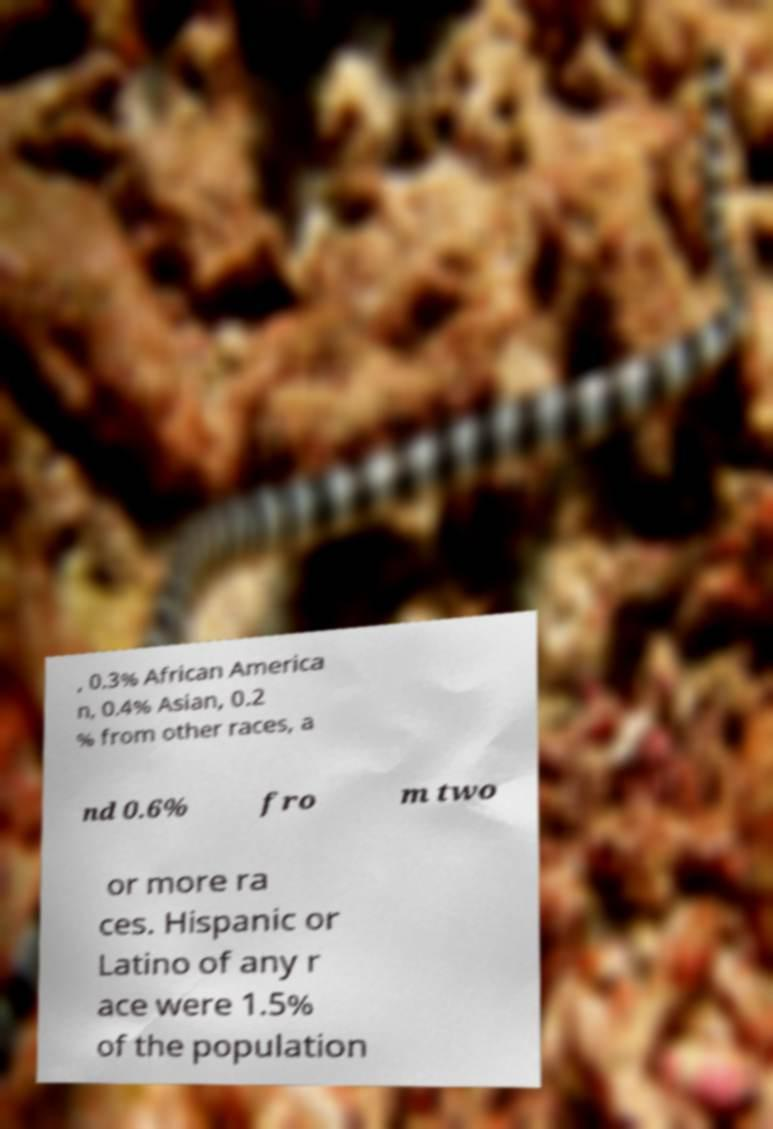Can you read and provide the text displayed in the image?This photo seems to have some interesting text. Can you extract and type it out for me? , 0.3% African America n, 0.4% Asian, 0.2 % from other races, a nd 0.6% fro m two or more ra ces. Hispanic or Latino of any r ace were 1.5% of the population 